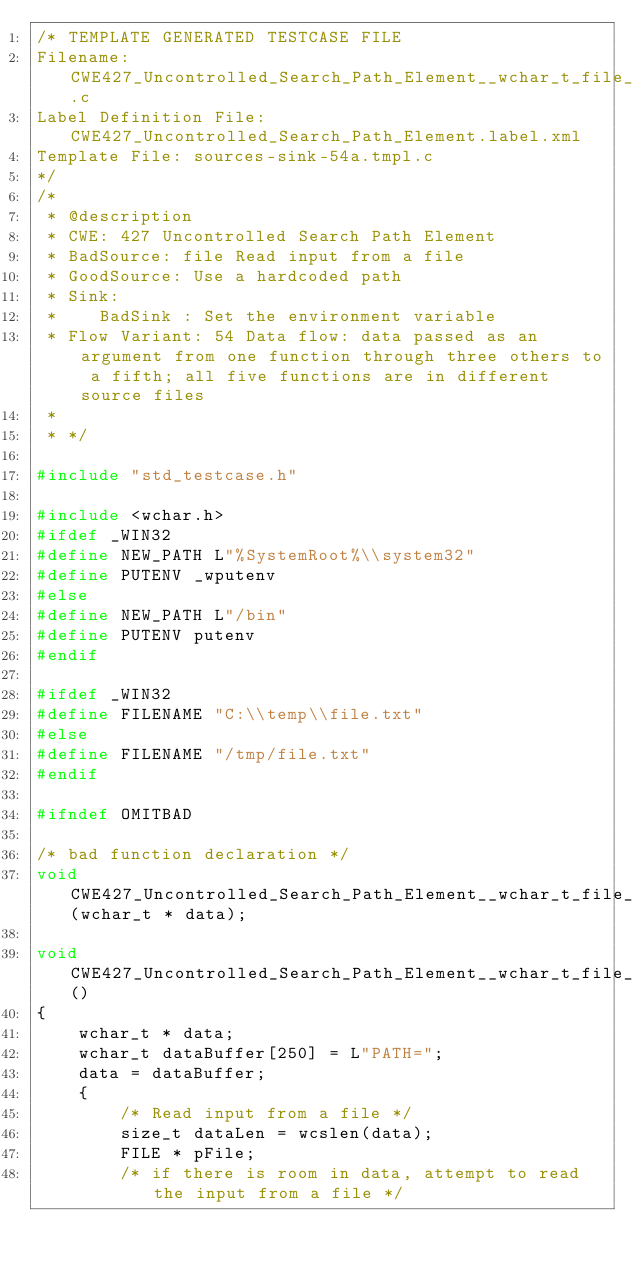<code> <loc_0><loc_0><loc_500><loc_500><_C_>/* TEMPLATE GENERATED TESTCASE FILE
Filename: CWE427_Uncontrolled_Search_Path_Element__wchar_t_file_54a.c
Label Definition File: CWE427_Uncontrolled_Search_Path_Element.label.xml
Template File: sources-sink-54a.tmpl.c
*/
/*
 * @description
 * CWE: 427 Uncontrolled Search Path Element
 * BadSource: file Read input from a file
 * GoodSource: Use a hardcoded path
 * Sink:
 *    BadSink : Set the environment variable
 * Flow Variant: 54 Data flow: data passed as an argument from one function through three others to a fifth; all five functions are in different source files
 *
 * */

#include "std_testcase.h"

#include <wchar.h>
#ifdef _WIN32
#define NEW_PATH L"%SystemRoot%\\system32"
#define PUTENV _wputenv
#else
#define NEW_PATH L"/bin"
#define PUTENV putenv
#endif

#ifdef _WIN32
#define FILENAME "C:\\temp\\file.txt"
#else
#define FILENAME "/tmp/file.txt"
#endif

#ifndef OMITBAD

/* bad function declaration */
void CWE427_Uncontrolled_Search_Path_Element__wchar_t_file_54b_badSink(wchar_t * data);

void CWE427_Uncontrolled_Search_Path_Element__wchar_t_file_54_bad()
{
    wchar_t * data;
    wchar_t dataBuffer[250] = L"PATH=";
    data = dataBuffer;
    {
        /* Read input from a file */
        size_t dataLen = wcslen(data);
        FILE * pFile;
        /* if there is room in data, attempt to read the input from a file */</code> 